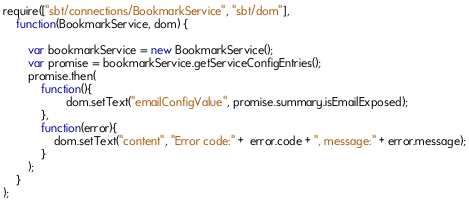<code> <loc_0><loc_0><loc_500><loc_500><_JavaScript_>require(["sbt/connections/BookmarkService", "sbt/dom"], 
    function(BookmarkService, dom) {
    
    	var bookmarkService = new BookmarkService();
    	var promise = bookmarkService.getServiceConfigEntries();
    	promise.then(
            function(){
                    dom.setText("emailConfigValue", promise.summary.isEmailExposed);
            },
            function(error){
                dom.setText("content", "Error code:" +  error.code + ", message:" + error.message);
            }       
    	);
    }
);</code> 